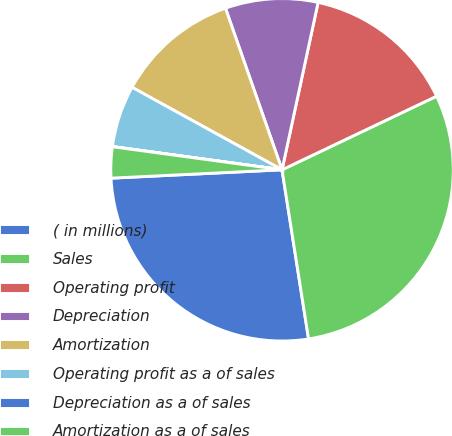Convert chart. <chart><loc_0><loc_0><loc_500><loc_500><pie_chart><fcel>( in millions)<fcel>Sales<fcel>Operating profit<fcel>Depreciation<fcel>Amortization<fcel>Operating profit as a of sales<fcel>Depreciation as a of sales<fcel>Amortization as a of sales<nl><fcel>26.7%<fcel>29.6%<fcel>14.55%<fcel>8.74%<fcel>11.64%<fcel>5.83%<fcel>0.02%<fcel>2.93%<nl></chart> 